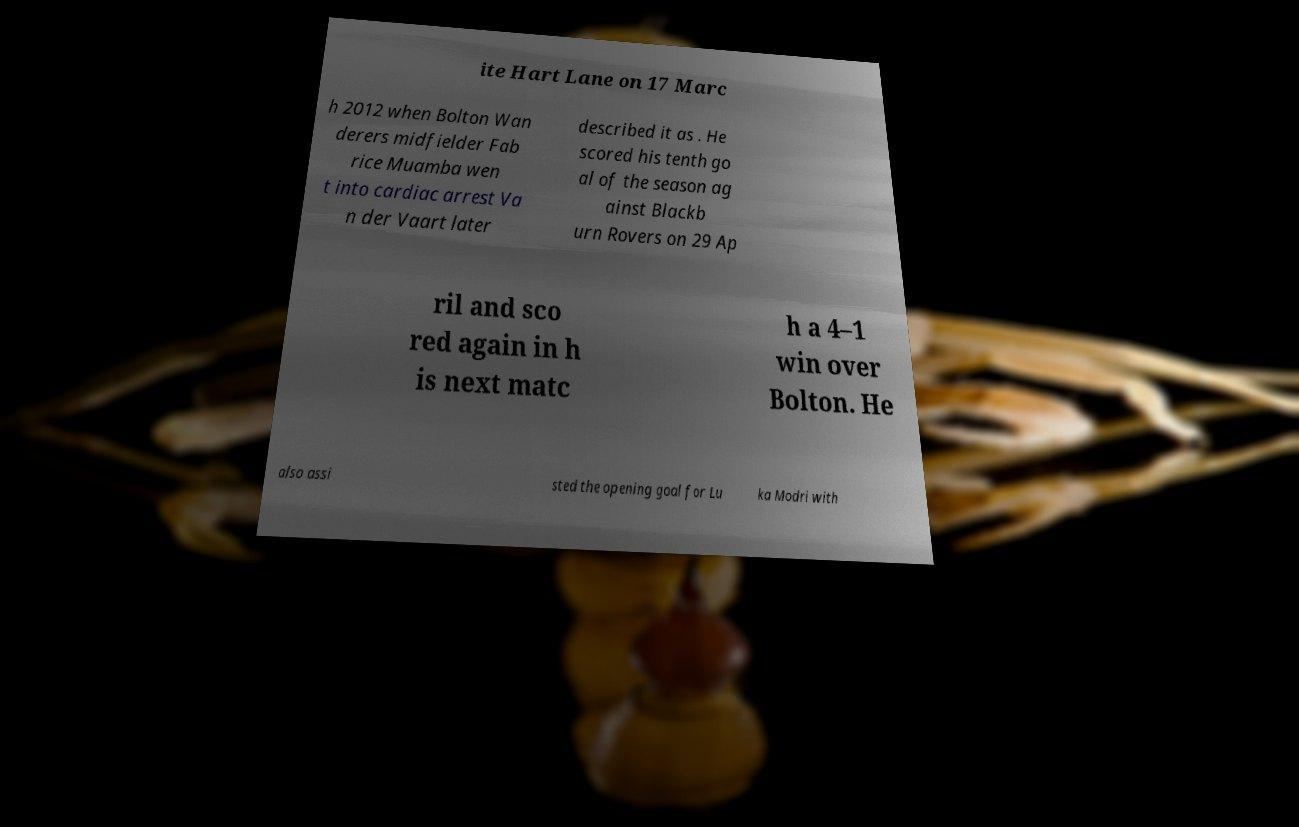Can you accurately transcribe the text from the provided image for me? ite Hart Lane on 17 Marc h 2012 when Bolton Wan derers midfielder Fab rice Muamba wen t into cardiac arrest Va n der Vaart later described it as . He scored his tenth go al of the season ag ainst Blackb urn Rovers on 29 Ap ril and sco red again in h is next matc h a 4–1 win over Bolton. He also assi sted the opening goal for Lu ka Modri with 